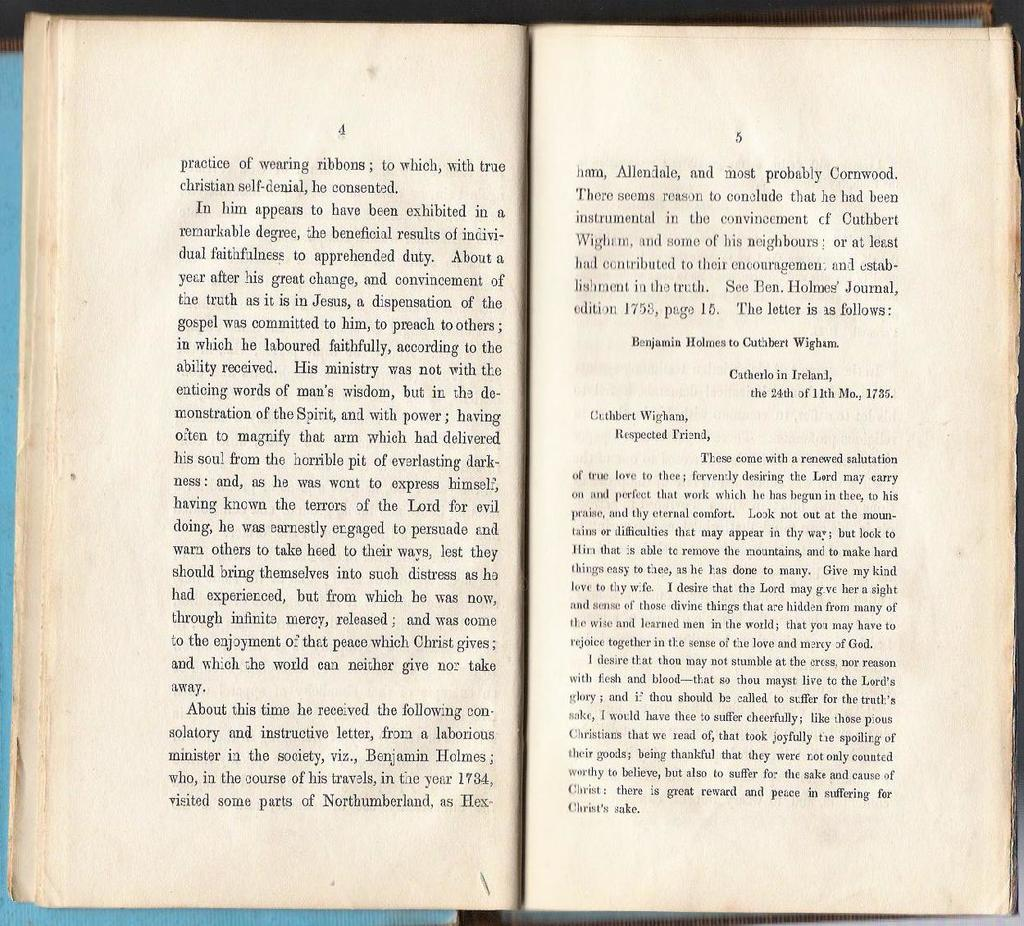<image>
Share a concise interpretation of the image provided. two pages of an open book with text written by cuthbert wigham. 